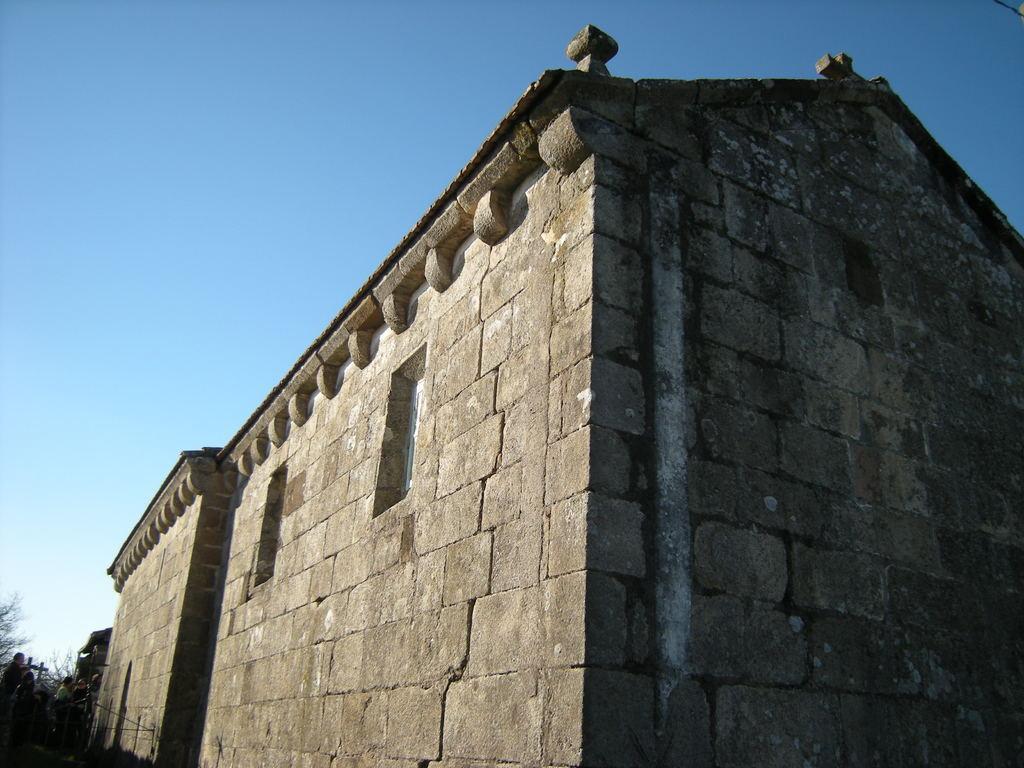In one or two sentences, can you explain what this image depicts? In this image we can see a building with a stone wall. In the left bottom corner we can see few people. Also there are trees. In the background there is sky. 